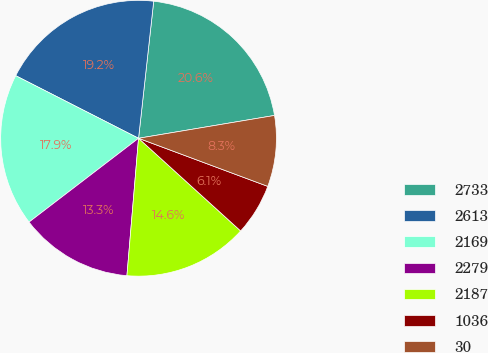<chart> <loc_0><loc_0><loc_500><loc_500><pie_chart><fcel>2733<fcel>2613<fcel>2169<fcel>2279<fcel>2187<fcel>1036<fcel>30<nl><fcel>20.6%<fcel>19.25%<fcel>17.9%<fcel>13.26%<fcel>14.61%<fcel>6.06%<fcel>8.32%<nl></chart> 